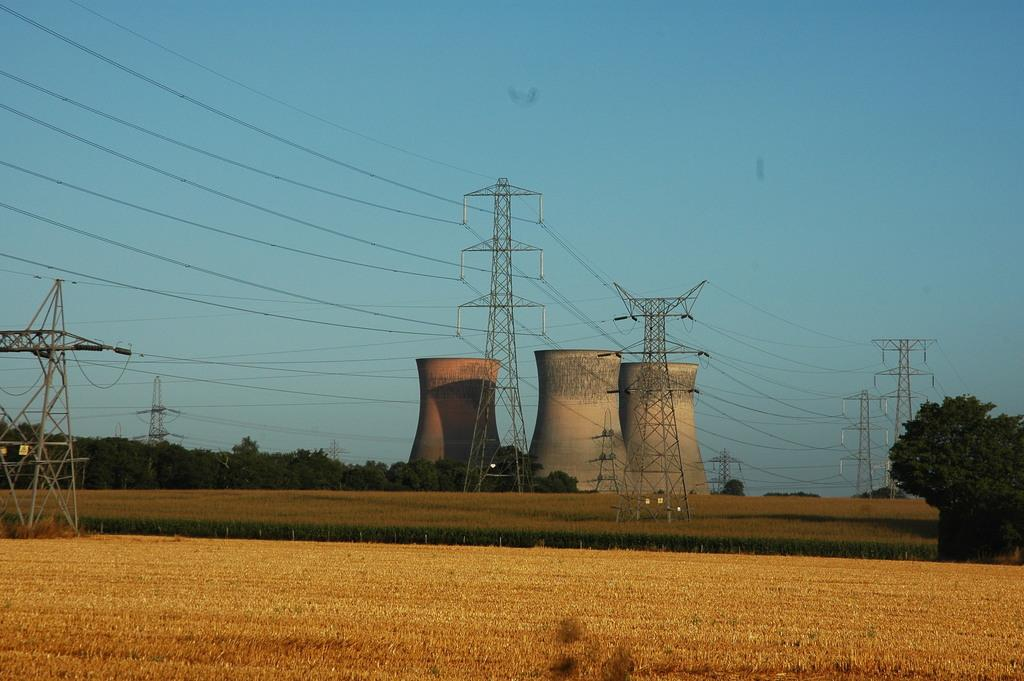What can be seen in the foreground of the image? In the foreground of the image, there are farming fields, poles, cables, cooling towers, and trees. What is visible in the sky in the image? The sky is visible in the image. What type of account is being advertised in the image? There is no account or advertisement present in the image. What type of rice is being harvested in the farming fields in the image? There is no rice being harvested in the image; the farming fields do not specify the type of crop being grown. 